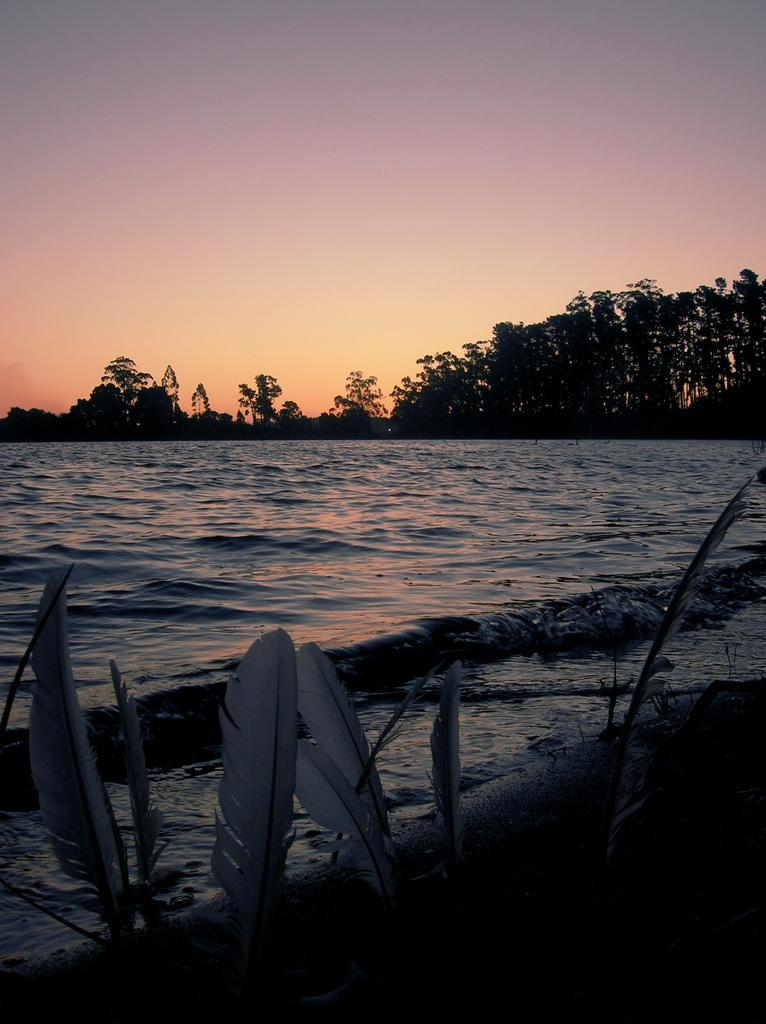What is the main feature in the center of the image? There is a river in the center of the image. What can be seen in the foreground of the image? There are plants in the foreground of the image. What type of vegetation is visible in the background of the image? There are trees in the background of the image. What is visible at the top of the image? The sky is visible at the top of the image. What type of steel is used to construct the bridge over the river in the image? There is no bridge visible in the image, so it is not possible to determine the type of steel used in its construction. 